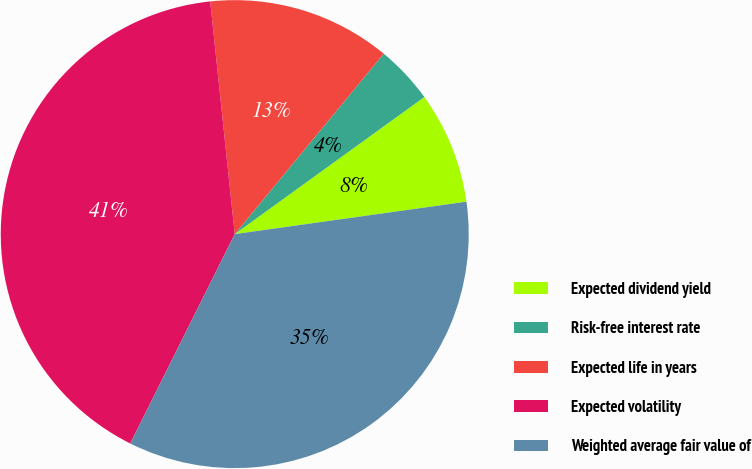Convert chart to OTSL. <chart><loc_0><loc_0><loc_500><loc_500><pie_chart><fcel>Expected dividend yield<fcel>Risk-free interest rate<fcel>Expected life in years<fcel>Expected volatility<fcel>Weighted average fair value of<nl><fcel>7.75%<fcel>4.05%<fcel>12.66%<fcel>40.96%<fcel>34.58%<nl></chart> 